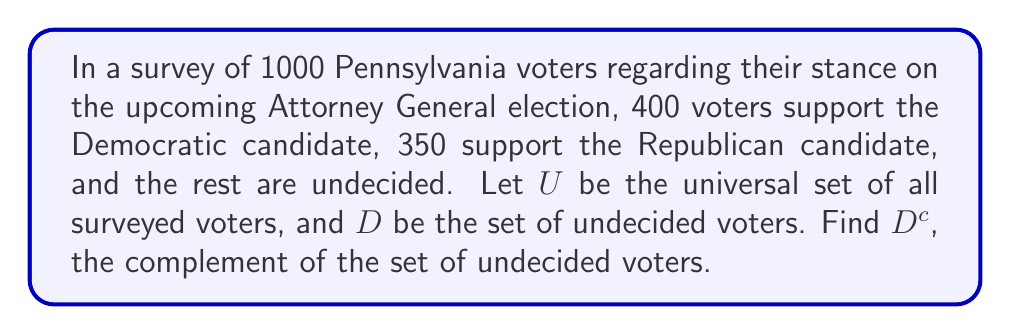Show me your answer to this math problem. To solve this problem, we need to follow these steps:

1. Determine the total number of voters: $|U| = 1000$

2. Calculate the number of decided voters:
   Democratic supporters: 400
   Republican supporters: 350
   Total decided voters: $400 + 350 = 750$

3. Find the number of undecided voters:
   $|D| = 1000 - 750 = 250$

4. The complement of set $D$, denoted as $D^c$, consists of all elements in the universal set $U$ that are not in $D$. In this case, $D^c$ represents all decided voters.

5. Therefore, $|D^c| = |U| - |D| = 1000 - 250 = 750$

The complement of the set of undecided voters $(D^c)$ contains 750 elements, which represents all the decided voters (both Democratic and Republican supporters).
Answer: $D^c = \{x \in U : x \text{ is a decided voter}\}$, where $|D^c| = 750$ 